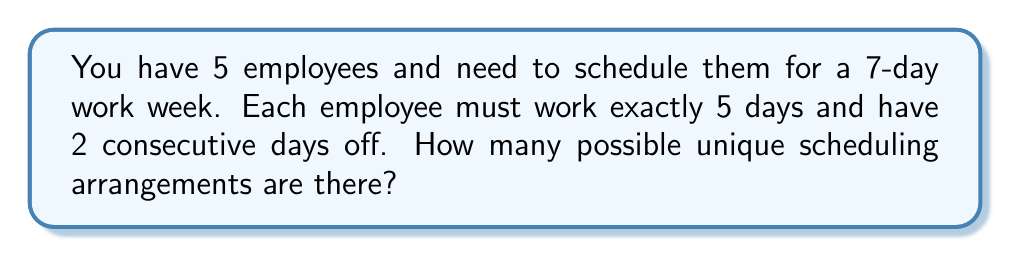Could you help me with this problem? Let's approach this step-by-step:

1) First, we need to understand that for each employee, we're essentially choosing a starting point for their 2-day break in a 7-day cycle.

2) For each employee, there are 7 possible starting points for their break:
   Day 1-2, Day 2-3, Day 3-4, Day 4-5, Day 5-6, Day 6-7, or Day 7-1

3) This means for the first employee, we have 7 choices.

4) For the second employee, we again have 7 choices, regardless of what we chose for the first employee.

5) This pattern continues for all 5 employees.

6) In combinatorics, when we have a series of independent choices, we multiply the number of options for each choice.

7) Therefore, the total number of possible scheduling arrangements is:

   $$ 7 \times 7 \times 7 \times 7 \times 7 = 7^5 $$

8) Calculating this:
   $$ 7^5 = 7 \times 7 \times 7 \times 7 \times 7 = 16,807 $$

Thus, there are 16,807 possible unique scheduling arrangements.
Answer: 16,807 